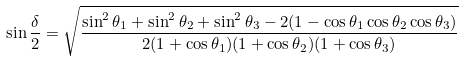Convert formula to latex. <formula><loc_0><loc_0><loc_500><loc_500>\sin \frac { \delta } { 2 } = \sqrt { \frac { \sin ^ { 2 } \theta _ { 1 } + \sin ^ { 2 } \theta _ { 2 } + \sin ^ { 2 } \theta _ { 3 } - 2 ( 1 - \cos \theta _ { 1 } \cos \theta _ { 2 } \cos \theta _ { 3 } ) } { 2 ( 1 + \cos \theta _ { 1 } ) ( 1 + \cos \theta _ { 2 } ) ( 1 + \cos \theta _ { 3 } ) } }</formula> 